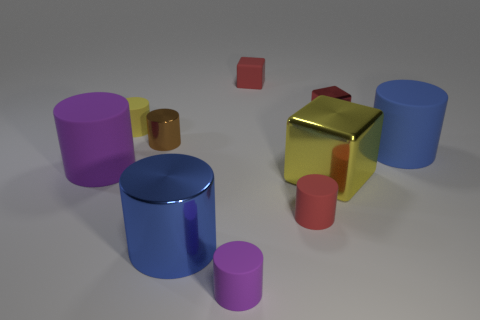Subtract all small shiny cubes. How many cubes are left? 2 Subtract all purple blocks. How many purple cylinders are left? 2 Subtract all red cubes. How many cubes are left? 1 Subtract all blocks. How many objects are left? 7 Subtract 4 cylinders. How many cylinders are left? 3 Subtract all brown cylinders. Subtract all green spheres. How many cylinders are left? 6 Subtract all small red matte cubes. Subtract all brown cylinders. How many objects are left? 8 Add 2 small red objects. How many small red objects are left? 5 Add 1 small red rubber cylinders. How many small red rubber cylinders exist? 2 Subtract 0 gray spheres. How many objects are left? 10 